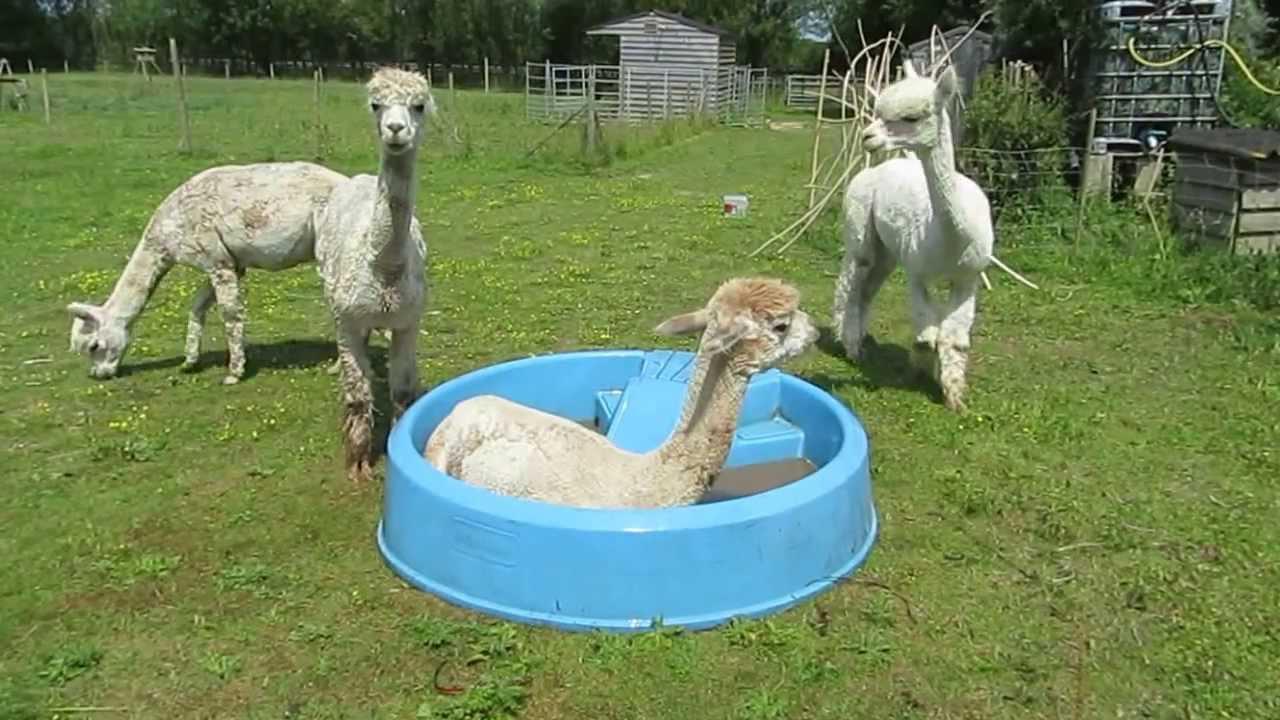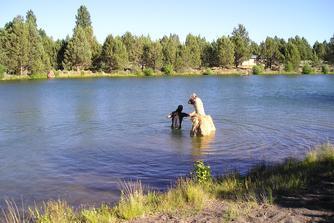The first image is the image on the left, the second image is the image on the right. For the images displayed, is the sentence "An alpaca is laying down in a small blue pool in one of the pictures." factually correct? Answer yes or no. Yes. The first image is the image on the left, the second image is the image on the right. Examine the images to the left and right. Is the description "One of the images shows an alpaca in a kiddie pool and the other image shows a llama in a lake." accurate? Answer yes or no. Yes. 